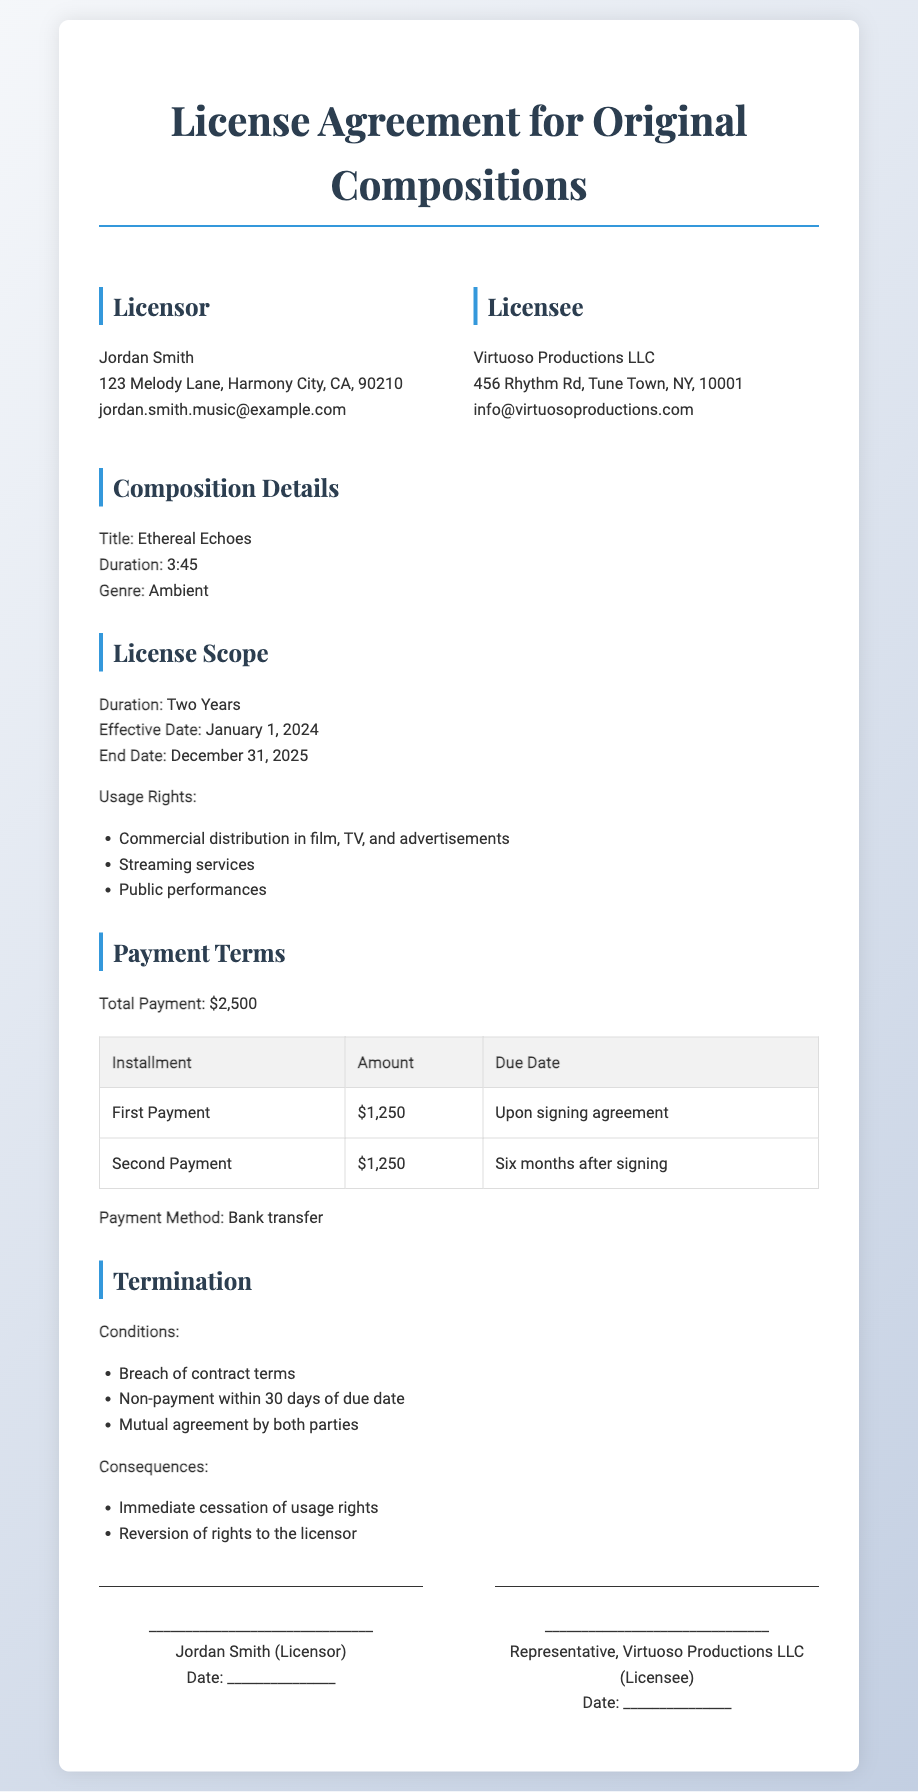what is the title of the composition? The title of the composition is listed under the Composition Details section.
Answer: Ethereal Echoes what is the total payment amount? The total payment is specified in the Payment Terms section of the document.
Answer: $2,500 when does the license agreement become effective? The effective date of the license agreement is indicated under the License Scope section.
Answer: January 1, 2024 how long is the duration of the license? The duration of the license can be found in the License Scope section of the document.
Answer: Two Years what are the usage rights granted? The usage rights are enumerated in the License Scope section.
Answer: Commercial distribution in film, TV, and advertisements; Streaming services; Public performances what happens if there is a breach of contract? The consequences of breach of contract are mentioned under the Termination section.
Answer: Immediate cessation of usage rights; Reversion of rights to the licensor when is the second payment due? The due date for the second payment is listed in the Payment Terms table.
Answer: Six months after signing who is the licensor? The name of the licensor is found in the party information section of the document.
Answer: Jordan Smith what is the payment method specified? The payment method is noted in the Payment Terms section of the document.
Answer: Bank transfer 